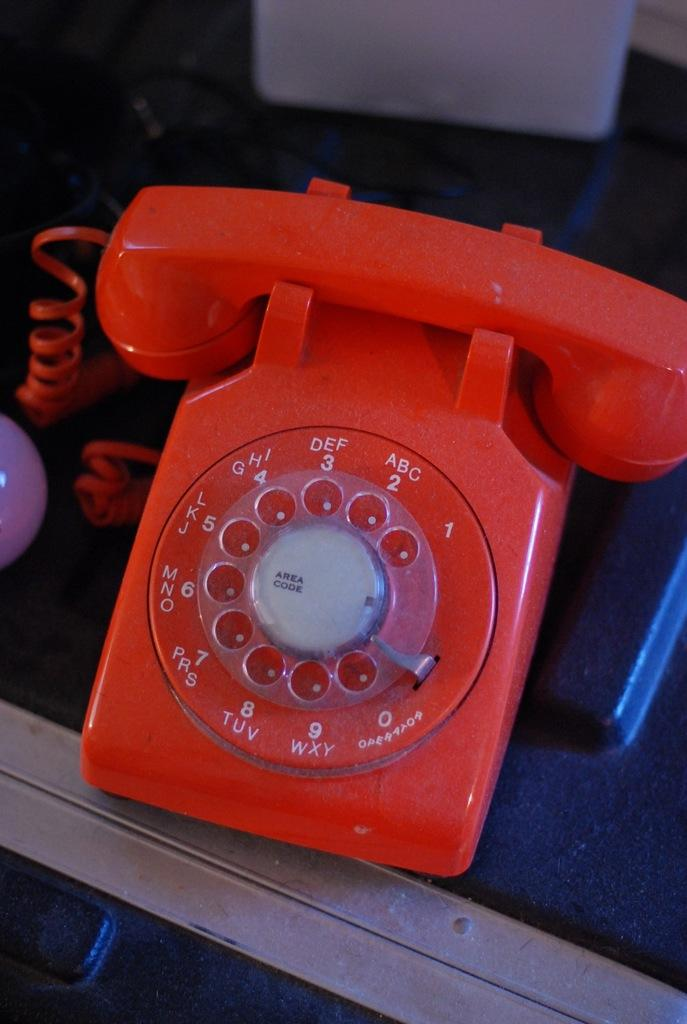Provide a one-sentence caption for the provided image. An orange dial phone features an Operator label on the zero number. 